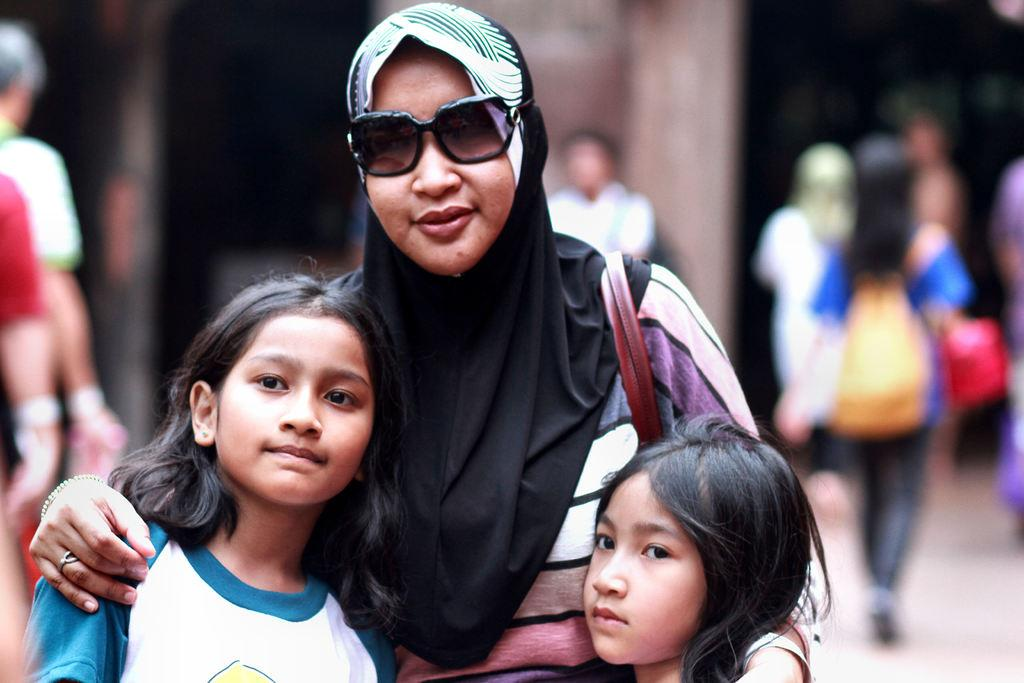How many people are present in the image? There are three people standing in the image. Can you describe the background of the image? The background of the image is blurry. What type of bells can be heard ringing in the image? There are no bells present in the image, and therefore no such sound can be heard. What is the color of the chin of the person on the left side of the image? There is no chin visible for the person on the left side of the image, as the image only shows the three people standing. 